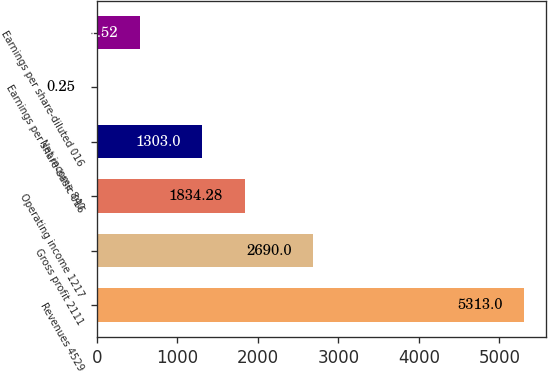<chart> <loc_0><loc_0><loc_500><loc_500><bar_chart><fcel>Revenues 4529<fcel>Gross profit 2111<fcel>Operating income 1217<fcel>Net income 840<fcel>Earnings per share-basic 016<fcel>Earnings per share-diluted 016<nl><fcel>5313<fcel>2690<fcel>1834.28<fcel>1303<fcel>0.25<fcel>531.52<nl></chart> 